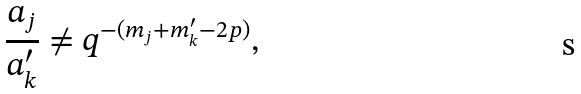Convert formula to latex. <formula><loc_0><loc_0><loc_500><loc_500>\frac { a _ { j } } { a ^ { \prime } _ { k } } \ne q ^ { - ( m _ { j } + m _ { k } ^ { \prime } - 2 p ) } ,</formula> 